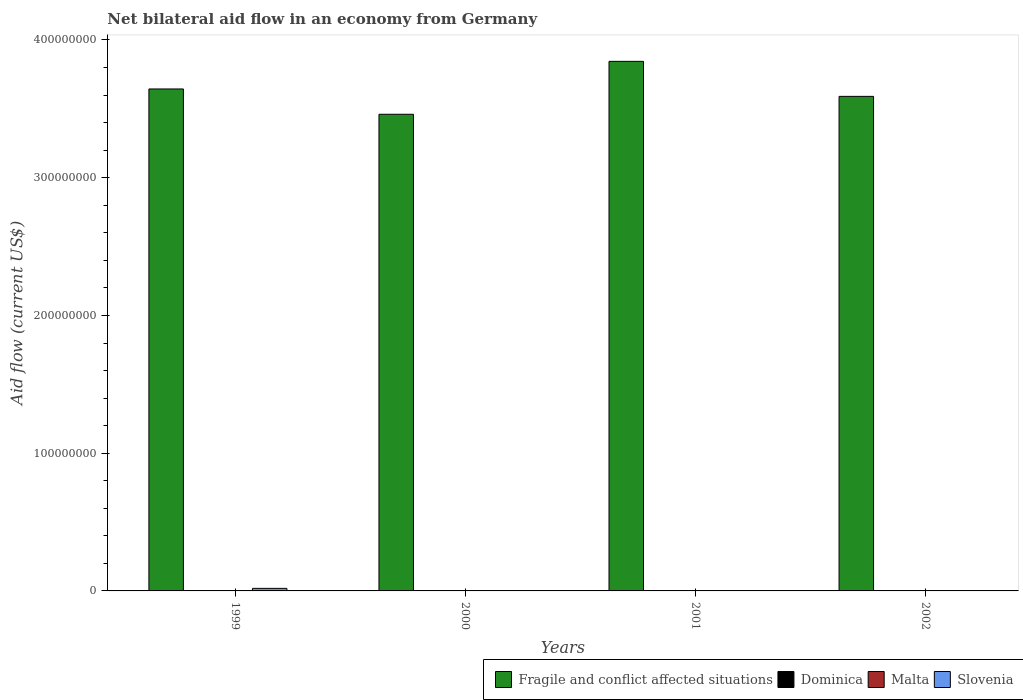How many groups of bars are there?
Your answer should be very brief. 4. Are the number of bars on each tick of the X-axis equal?
Offer a terse response. No. How many bars are there on the 4th tick from the right?
Give a very brief answer. 3. Across all years, what is the maximum net bilateral aid flow in Slovenia?
Ensure brevity in your answer.  1.85e+06. Across all years, what is the minimum net bilateral aid flow in Fragile and conflict affected situations?
Your answer should be very brief. 3.46e+08. What is the average net bilateral aid flow in Dominica per year?
Your response must be concise. 4.75e+04. In the year 2002, what is the difference between the net bilateral aid flow in Dominica and net bilateral aid flow in Fragile and conflict affected situations?
Your answer should be very brief. -3.59e+08. What is the ratio of the net bilateral aid flow in Fragile and conflict affected situations in 1999 to that in 2000?
Provide a succinct answer. 1.05. Is the net bilateral aid flow in Dominica in 2000 less than that in 2001?
Offer a terse response. No. Is the difference between the net bilateral aid flow in Dominica in 1999 and 2002 greater than the difference between the net bilateral aid flow in Fragile and conflict affected situations in 1999 and 2002?
Your answer should be compact. No. What is the difference between the highest and the second highest net bilateral aid flow in Dominica?
Make the answer very short. 3.00e+04. What is the difference between the highest and the lowest net bilateral aid flow in Fragile and conflict affected situations?
Give a very brief answer. 3.84e+07. Is the sum of the net bilateral aid flow in Fragile and conflict affected situations in 2000 and 2001 greater than the maximum net bilateral aid flow in Dominica across all years?
Your answer should be compact. Yes. Is it the case that in every year, the sum of the net bilateral aid flow in Slovenia and net bilateral aid flow in Malta is greater than the sum of net bilateral aid flow in Fragile and conflict affected situations and net bilateral aid flow in Dominica?
Your answer should be very brief. No. Are all the bars in the graph horizontal?
Your response must be concise. No. How many years are there in the graph?
Offer a terse response. 4. Are the values on the major ticks of Y-axis written in scientific E-notation?
Keep it short and to the point. No. Does the graph contain any zero values?
Give a very brief answer. Yes. Does the graph contain grids?
Make the answer very short. No. How many legend labels are there?
Your response must be concise. 4. What is the title of the graph?
Keep it short and to the point. Net bilateral aid flow in an economy from Germany. What is the label or title of the Y-axis?
Ensure brevity in your answer.  Aid flow (current US$). What is the Aid flow (current US$) of Fragile and conflict affected situations in 1999?
Offer a very short reply. 3.64e+08. What is the Aid flow (current US$) of Dominica in 1999?
Make the answer very short. 2.00e+04. What is the Aid flow (current US$) of Malta in 1999?
Your answer should be very brief. 0. What is the Aid flow (current US$) in Slovenia in 1999?
Make the answer very short. 1.85e+06. What is the Aid flow (current US$) in Fragile and conflict affected situations in 2000?
Give a very brief answer. 3.46e+08. What is the Aid flow (current US$) in Dominica in 2000?
Keep it short and to the point. 8.00e+04. What is the Aid flow (current US$) of Malta in 2000?
Provide a short and direct response. 0. What is the Aid flow (current US$) in Slovenia in 2000?
Ensure brevity in your answer.  0. What is the Aid flow (current US$) of Fragile and conflict affected situations in 2001?
Give a very brief answer. 3.84e+08. What is the Aid flow (current US$) in Dominica in 2001?
Provide a short and direct response. 4.00e+04. What is the Aid flow (current US$) in Slovenia in 2001?
Provide a short and direct response. 0. What is the Aid flow (current US$) in Fragile and conflict affected situations in 2002?
Offer a terse response. 3.59e+08. What is the Aid flow (current US$) of Slovenia in 2002?
Offer a very short reply. 0. Across all years, what is the maximum Aid flow (current US$) of Fragile and conflict affected situations?
Provide a succinct answer. 3.84e+08. Across all years, what is the maximum Aid flow (current US$) of Dominica?
Your answer should be very brief. 8.00e+04. Across all years, what is the maximum Aid flow (current US$) of Slovenia?
Your response must be concise. 1.85e+06. Across all years, what is the minimum Aid flow (current US$) of Fragile and conflict affected situations?
Keep it short and to the point. 3.46e+08. Across all years, what is the minimum Aid flow (current US$) in Dominica?
Your response must be concise. 2.00e+04. Across all years, what is the minimum Aid flow (current US$) of Slovenia?
Give a very brief answer. 0. What is the total Aid flow (current US$) in Fragile and conflict affected situations in the graph?
Offer a terse response. 1.45e+09. What is the total Aid flow (current US$) of Dominica in the graph?
Offer a terse response. 1.90e+05. What is the total Aid flow (current US$) in Malta in the graph?
Offer a terse response. 0. What is the total Aid flow (current US$) of Slovenia in the graph?
Keep it short and to the point. 1.85e+06. What is the difference between the Aid flow (current US$) in Fragile and conflict affected situations in 1999 and that in 2000?
Provide a short and direct response. 1.84e+07. What is the difference between the Aid flow (current US$) of Dominica in 1999 and that in 2000?
Make the answer very short. -6.00e+04. What is the difference between the Aid flow (current US$) in Fragile and conflict affected situations in 1999 and that in 2001?
Provide a short and direct response. -2.00e+07. What is the difference between the Aid flow (current US$) of Fragile and conflict affected situations in 1999 and that in 2002?
Provide a succinct answer. 5.38e+06. What is the difference between the Aid flow (current US$) of Dominica in 1999 and that in 2002?
Keep it short and to the point. -3.00e+04. What is the difference between the Aid flow (current US$) in Fragile and conflict affected situations in 2000 and that in 2001?
Provide a short and direct response. -3.84e+07. What is the difference between the Aid flow (current US$) of Fragile and conflict affected situations in 2000 and that in 2002?
Provide a succinct answer. -1.30e+07. What is the difference between the Aid flow (current US$) of Fragile and conflict affected situations in 2001 and that in 2002?
Offer a very short reply. 2.54e+07. What is the difference between the Aid flow (current US$) in Dominica in 2001 and that in 2002?
Make the answer very short. -10000. What is the difference between the Aid flow (current US$) in Fragile and conflict affected situations in 1999 and the Aid flow (current US$) in Dominica in 2000?
Your response must be concise. 3.64e+08. What is the difference between the Aid flow (current US$) in Fragile and conflict affected situations in 1999 and the Aid flow (current US$) in Dominica in 2001?
Offer a terse response. 3.64e+08. What is the difference between the Aid flow (current US$) in Fragile and conflict affected situations in 1999 and the Aid flow (current US$) in Dominica in 2002?
Keep it short and to the point. 3.64e+08. What is the difference between the Aid flow (current US$) in Fragile and conflict affected situations in 2000 and the Aid flow (current US$) in Dominica in 2001?
Offer a terse response. 3.46e+08. What is the difference between the Aid flow (current US$) of Fragile and conflict affected situations in 2000 and the Aid flow (current US$) of Dominica in 2002?
Offer a very short reply. 3.46e+08. What is the difference between the Aid flow (current US$) of Fragile and conflict affected situations in 2001 and the Aid flow (current US$) of Dominica in 2002?
Keep it short and to the point. 3.84e+08. What is the average Aid flow (current US$) in Fragile and conflict affected situations per year?
Your response must be concise. 3.64e+08. What is the average Aid flow (current US$) of Dominica per year?
Offer a very short reply. 4.75e+04. What is the average Aid flow (current US$) of Slovenia per year?
Provide a succinct answer. 4.62e+05. In the year 1999, what is the difference between the Aid flow (current US$) of Fragile and conflict affected situations and Aid flow (current US$) of Dominica?
Provide a short and direct response. 3.64e+08. In the year 1999, what is the difference between the Aid flow (current US$) in Fragile and conflict affected situations and Aid flow (current US$) in Slovenia?
Provide a succinct answer. 3.63e+08. In the year 1999, what is the difference between the Aid flow (current US$) of Dominica and Aid flow (current US$) of Slovenia?
Offer a terse response. -1.83e+06. In the year 2000, what is the difference between the Aid flow (current US$) of Fragile and conflict affected situations and Aid flow (current US$) of Dominica?
Make the answer very short. 3.46e+08. In the year 2001, what is the difference between the Aid flow (current US$) in Fragile and conflict affected situations and Aid flow (current US$) in Dominica?
Your answer should be very brief. 3.84e+08. In the year 2002, what is the difference between the Aid flow (current US$) of Fragile and conflict affected situations and Aid flow (current US$) of Dominica?
Provide a succinct answer. 3.59e+08. What is the ratio of the Aid flow (current US$) of Fragile and conflict affected situations in 1999 to that in 2000?
Provide a succinct answer. 1.05. What is the ratio of the Aid flow (current US$) in Dominica in 1999 to that in 2000?
Provide a short and direct response. 0.25. What is the ratio of the Aid flow (current US$) in Fragile and conflict affected situations in 1999 to that in 2001?
Provide a short and direct response. 0.95. What is the ratio of the Aid flow (current US$) in Dominica in 1999 to that in 2001?
Give a very brief answer. 0.5. What is the ratio of the Aid flow (current US$) in Fragile and conflict affected situations in 1999 to that in 2002?
Provide a succinct answer. 1.01. What is the ratio of the Aid flow (current US$) in Fragile and conflict affected situations in 2000 to that in 2001?
Provide a succinct answer. 0.9. What is the ratio of the Aid flow (current US$) of Fragile and conflict affected situations in 2000 to that in 2002?
Keep it short and to the point. 0.96. What is the ratio of the Aid flow (current US$) in Dominica in 2000 to that in 2002?
Keep it short and to the point. 1.6. What is the ratio of the Aid flow (current US$) in Fragile and conflict affected situations in 2001 to that in 2002?
Offer a terse response. 1.07. What is the ratio of the Aid flow (current US$) of Dominica in 2001 to that in 2002?
Your answer should be compact. 0.8. What is the difference between the highest and the second highest Aid flow (current US$) in Fragile and conflict affected situations?
Provide a succinct answer. 2.00e+07. What is the difference between the highest and the lowest Aid flow (current US$) of Fragile and conflict affected situations?
Your response must be concise. 3.84e+07. What is the difference between the highest and the lowest Aid flow (current US$) in Slovenia?
Make the answer very short. 1.85e+06. 